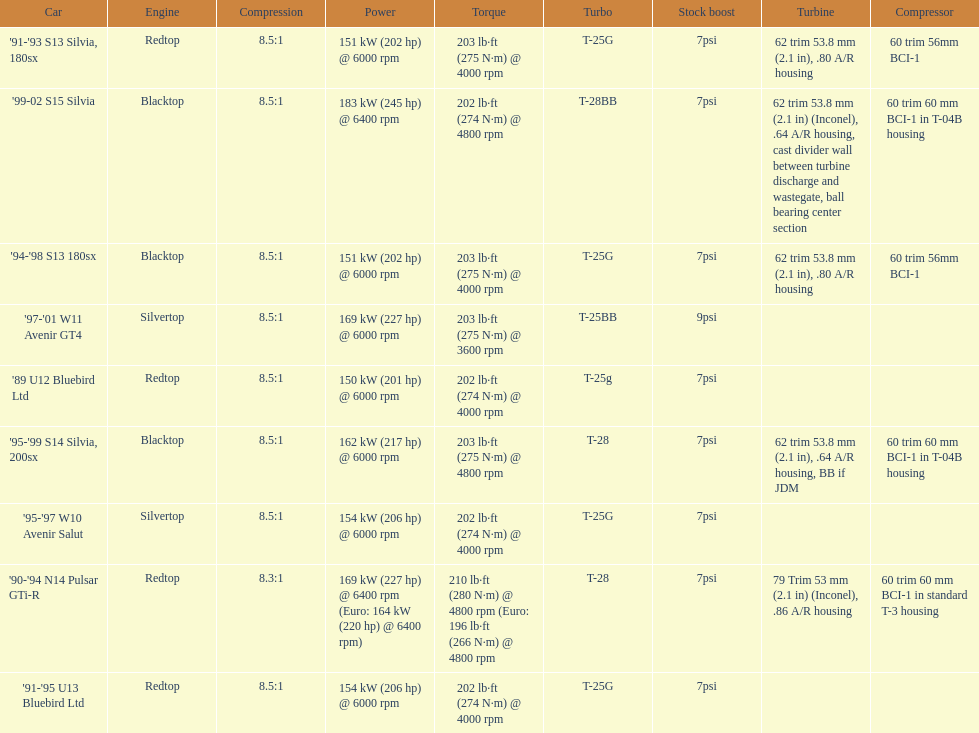How many models used the redtop engine? 4. 